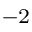<formula> <loc_0><loc_0><loc_500><loc_500>^ { - 2 }</formula> 